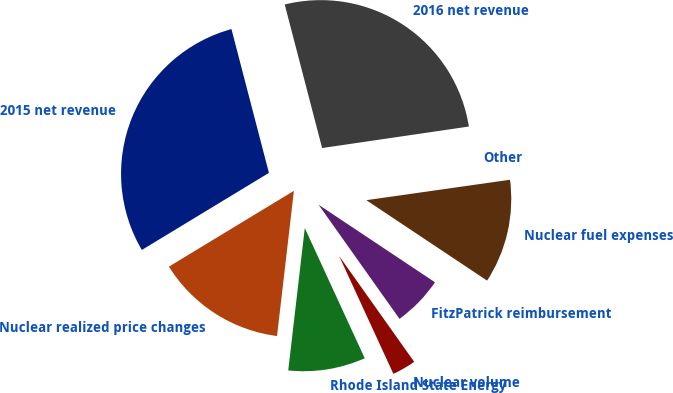Convert chart to OTSL. <chart><loc_0><loc_0><loc_500><loc_500><pie_chart><fcel>2015 net revenue<fcel>Nuclear realized price changes<fcel>Rhode Island State Energy<fcel>Nuclear volume<fcel>FitzPatrick reimbursement<fcel>Nuclear fuel expenses<fcel>Other<fcel>2016 net revenue<nl><fcel>29.62%<fcel>14.48%<fcel>8.71%<fcel>2.95%<fcel>5.83%<fcel>11.6%<fcel>0.07%<fcel>26.74%<nl></chart> 